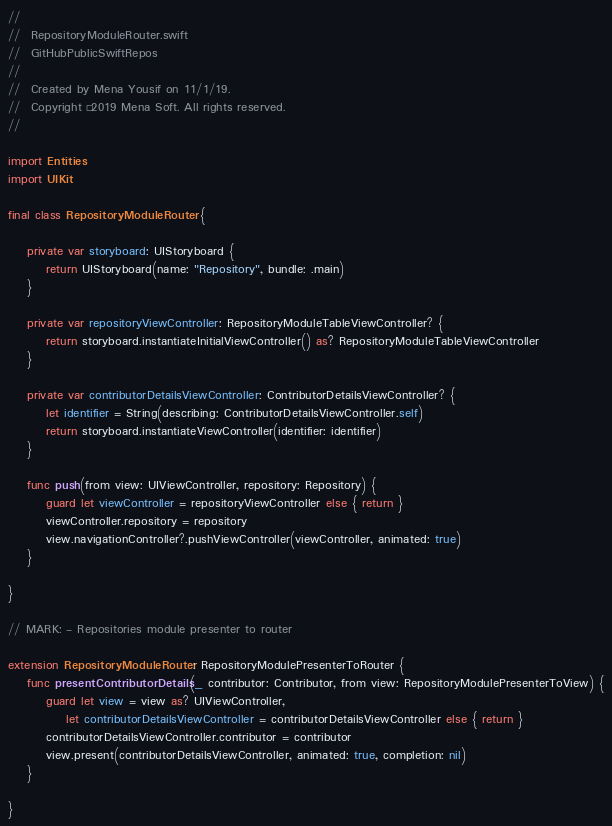Convert code to text. <code><loc_0><loc_0><loc_500><loc_500><_Swift_>//
//  RepositoryModuleRouter.swift
//  GitHubPublicSwiftRepos
//
//  Created by Mena Yousif on 11/1/19.
//  Copyright © 2019 Mena Soft. All rights reserved.
//

import Entities
import UIKit

final class RepositoryModuleRouter {

    private var storyboard: UIStoryboard {
        return UIStoryboard(name: "Repository", bundle: .main)
    }

    private var repositoryViewController: RepositoryModuleTableViewController? {
        return storyboard.instantiateInitialViewController() as? RepositoryModuleTableViewController
    }

    private var contributorDetailsViewController: ContributorDetailsViewController? {
        let identifier = String(describing: ContributorDetailsViewController.self)
        return storyboard.instantiateViewController(identifier: identifier)
    }

    func push(from view: UIViewController, repository: Repository) {
        guard let viewController = repositoryViewController else { return }
        viewController.repository = repository
        view.navigationController?.pushViewController(viewController, animated: true)
    }

}

// MARK: - Repositories module presenter to router

extension RepositoryModuleRouter: RepositoryModulePresenterToRouter {
    func presentContributorDetails(_ contributor: Contributor, from view: RepositoryModulePresenterToView) {
        guard let view = view as? UIViewController,
            let contributorDetailsViewController = contributorDetailsViewController else { return }
        contributorDetailsViewController.contributor = contributor
        view.present(contributorDetailsViewController, animated: true, completion: nil)
    }

}
</code> 